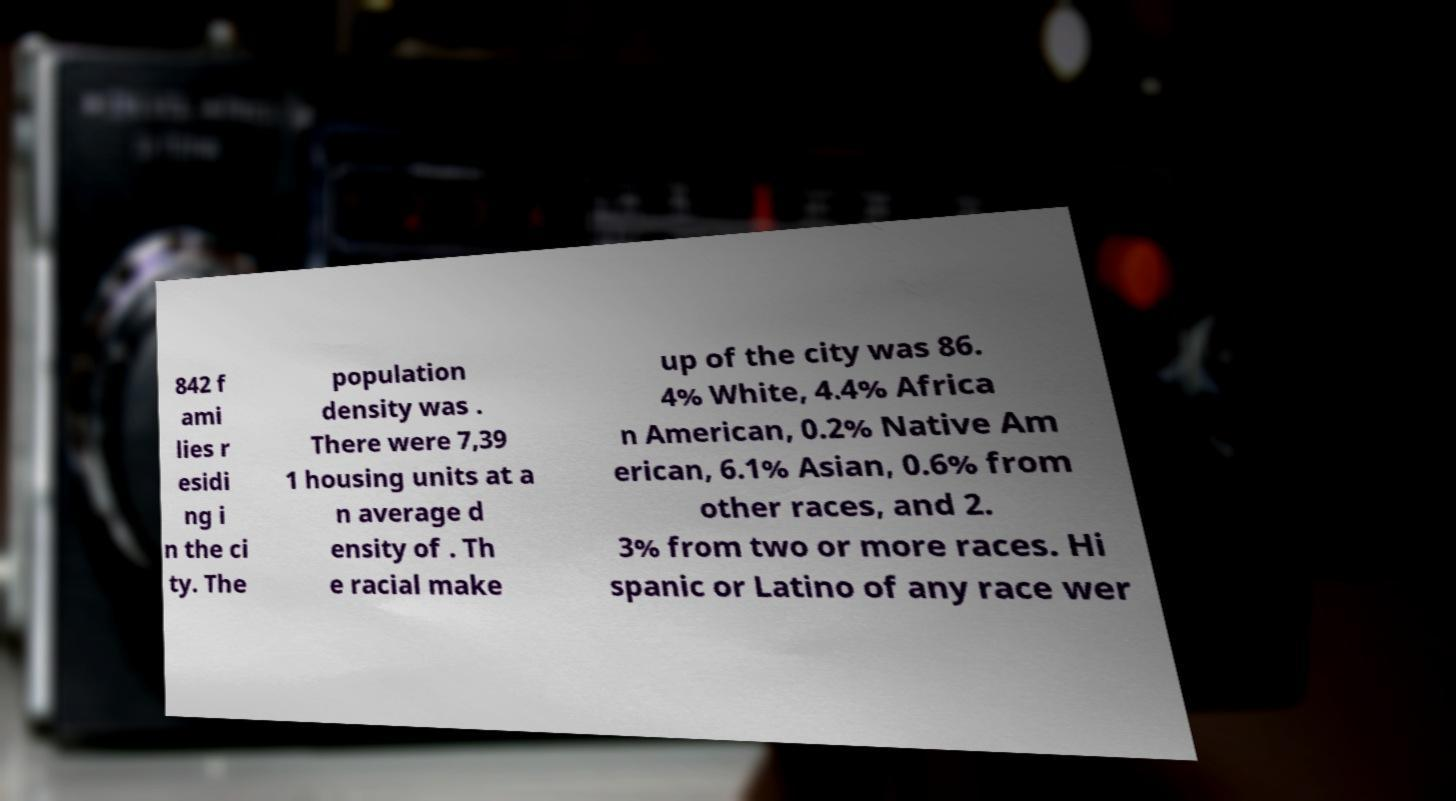Could you extract and type out the text from this image? 842 f ami lies r esidi ng i n the ci ty. The population density was . There were 7,39 1 housing units at a n average d ensity of . Th e racial make up of the city was 86. 4% White, 4.4% Africa n American, 0.2% Native Am erican, 6.1% Asian, 0.6% from other races, and 2. 3% from two or more races. Hi spanic or Latino of any race wer 